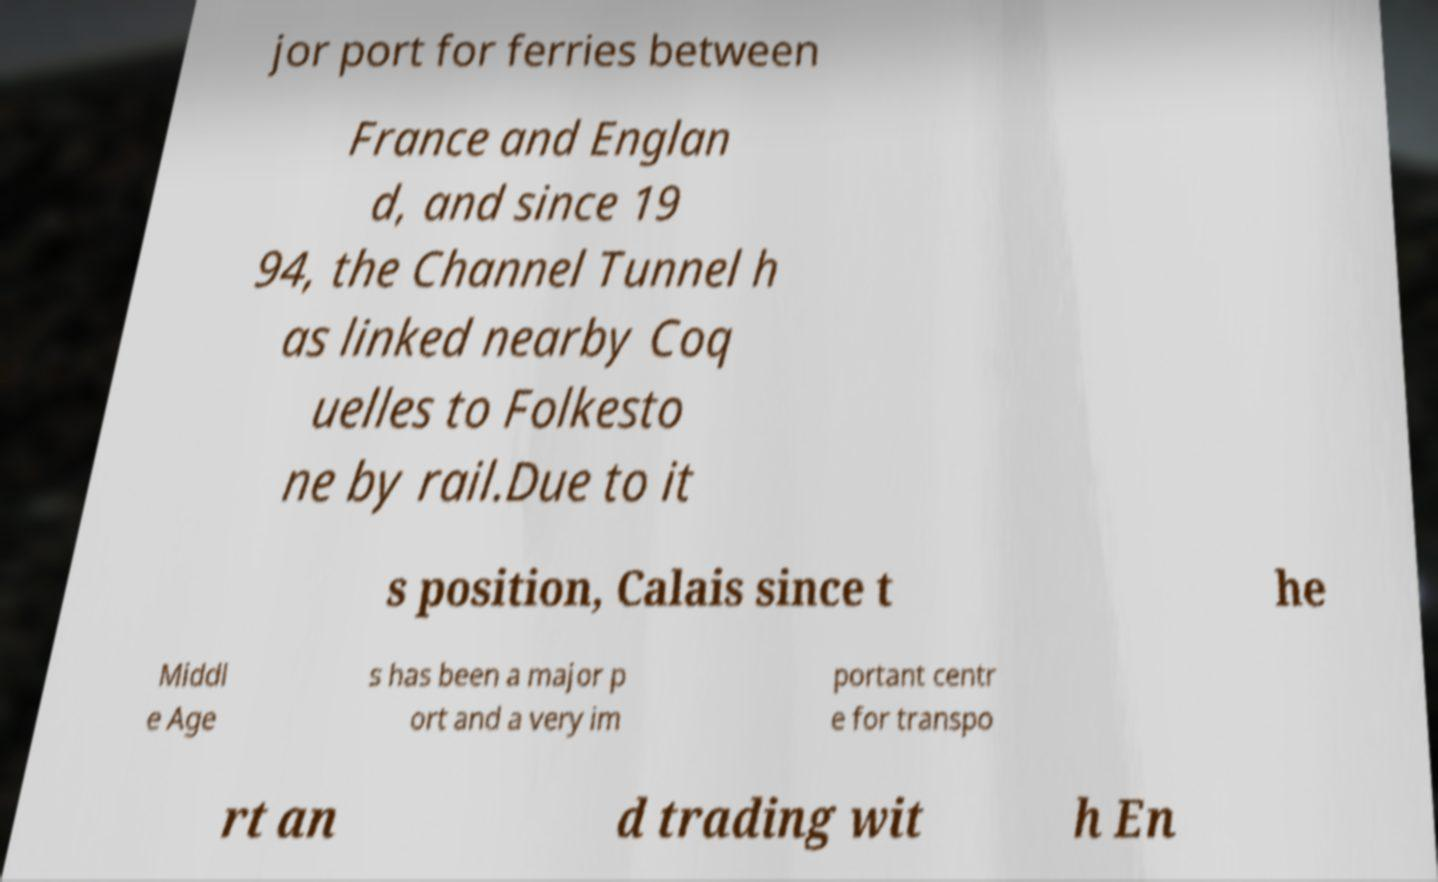What messages or text are displayed in this image? I need them in a readable, typed format. jor port for ferries between France and Englan d, and since 19 94, the Channel Tunnel h as linked nearby Coq uelles to Folkesto ne by rail.Due to it s position, Calais since t he Middl e Age s has been a major p ort and a very im portant centr e for transpo rt an d trading wit h En 